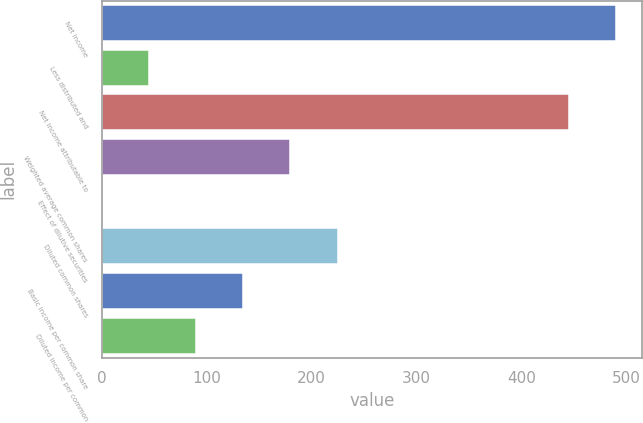<chart> <loc_0><loc_0><loc_500><loc_500><bar_chart><fcel>Net income<fcel>Less distributed and<fcel>Net income attributable to<fcel>Weighted average common shares<fcel>Effect of dilutive securities<fcel>Diluted common shares<fcel>Basic income per common share<fcel>Diluted income per common<nl><fcel>490.14<fcel>45.14<fcel>445.2<fcel>179.96<fcel>0.2<fcel>224.9<fcel>135.02<fcel>90.08<nl></chart> 